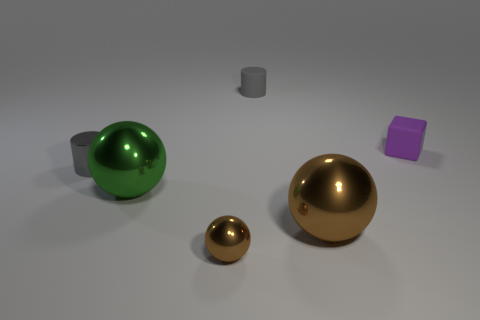Subtract all brown shiny spheres. How many spheres are left? 1 Add 3 tiny purple rubber blocks. How many objects exist? 9 Subtract all yellow cubes. How many brown balls are left? 2 Subtract all green balls. How many balls are left? 2 Subtract all blocks. How many objects are left? 5 Subtract 1 cylinders. How many cylinders are left? 1 Add 5 matte cubes. How many matte cubes exist? 6 Subtract 0 cyan spheres. How many objects are left? 6 Subtract all green balls. Subtract all blue cubes. How many balls are left? 2 Subtract all blue shiny blocks. Subtract all big brown metallic spheres. How many objects are left? 5 